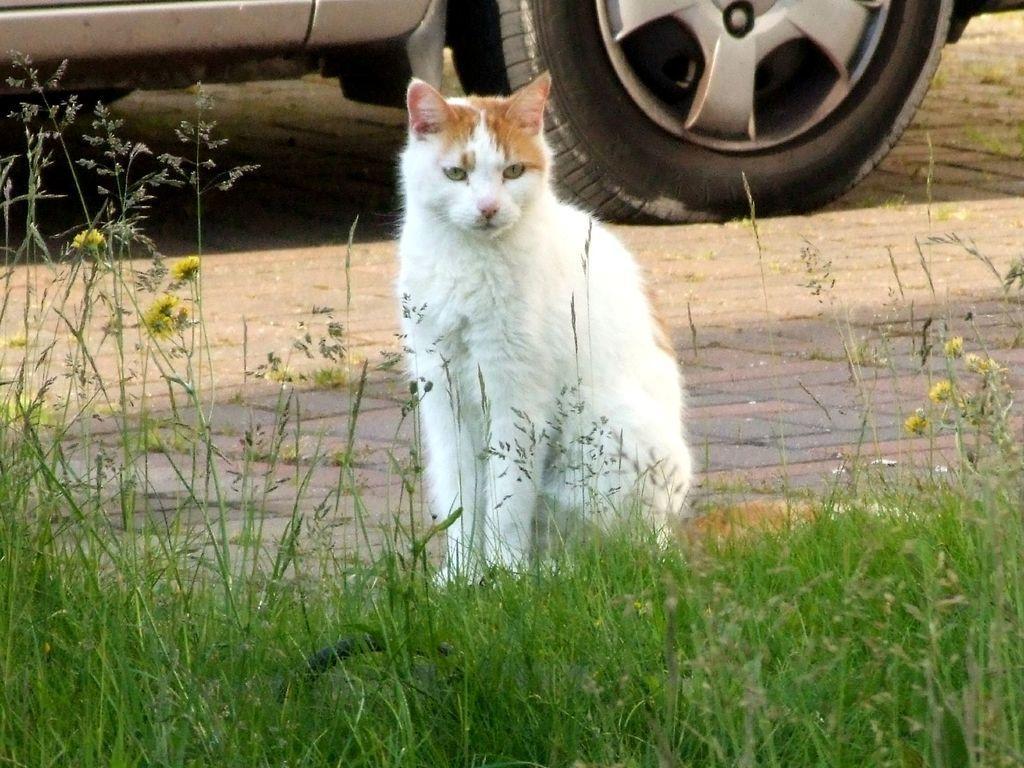In one or two sentences, can you explain what this image depicts? In the center of the image there is a cat. At the bottom there is grass. In the background there is a car on the road. 